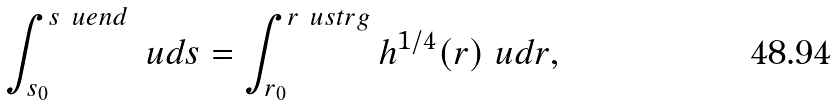<formula> <loc_0><loc_0><loc_500><loc_500>\int _ { s _ { 0 } } ^ { s _ { \ } u e n d } \ u d s = \int _ { r _ { 0 } } ^ { r _ { \ } u s t r g } h ^ { 1 / 4 } ( r ) \ u d r ,</formula> 